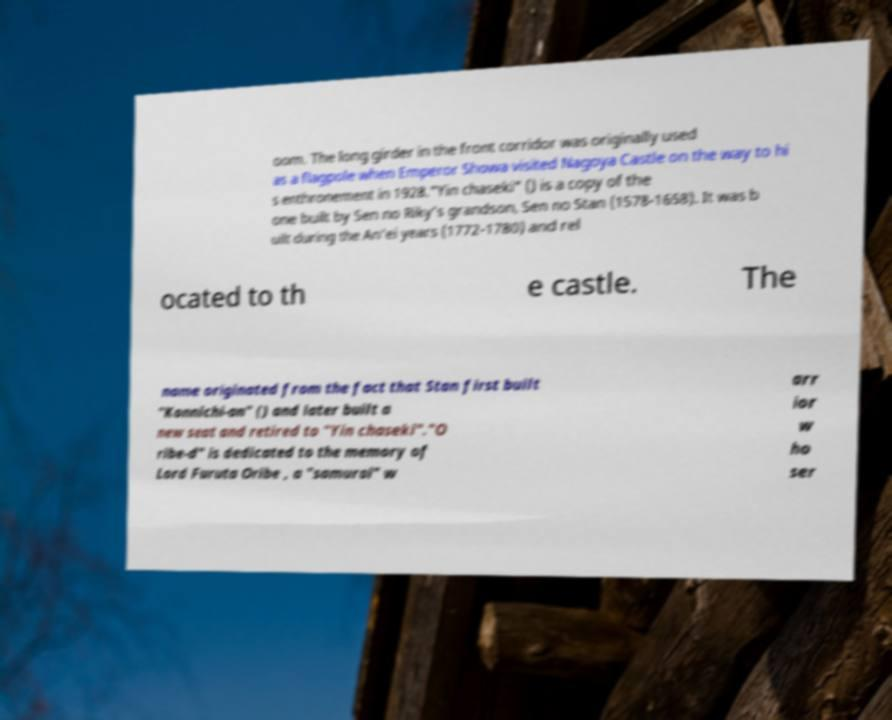For documentation purposes, I need the text within this image transcribed. Could you provide that? oom. The long girder in the front corridor was originally used as a flagpole when Emperor Showa visited Nagoya Castle on the way to hi s enthronement in 1928."Yin chaseki" () is a copy of the one built by Sen no Riky's grandson, Sen no Stan (1578-1658). It was b uilt during the An'ei years (1772-1780) and rel ocated to th e castle. The name originated from the fact that Stan first built "Konnichi-an" () and later built a new seat and retired to "Yin chaseki"."O ribe-d" is dedicated to the memory of Lord Furuta Oribe , a "samurai" w arr ior w ho ser 